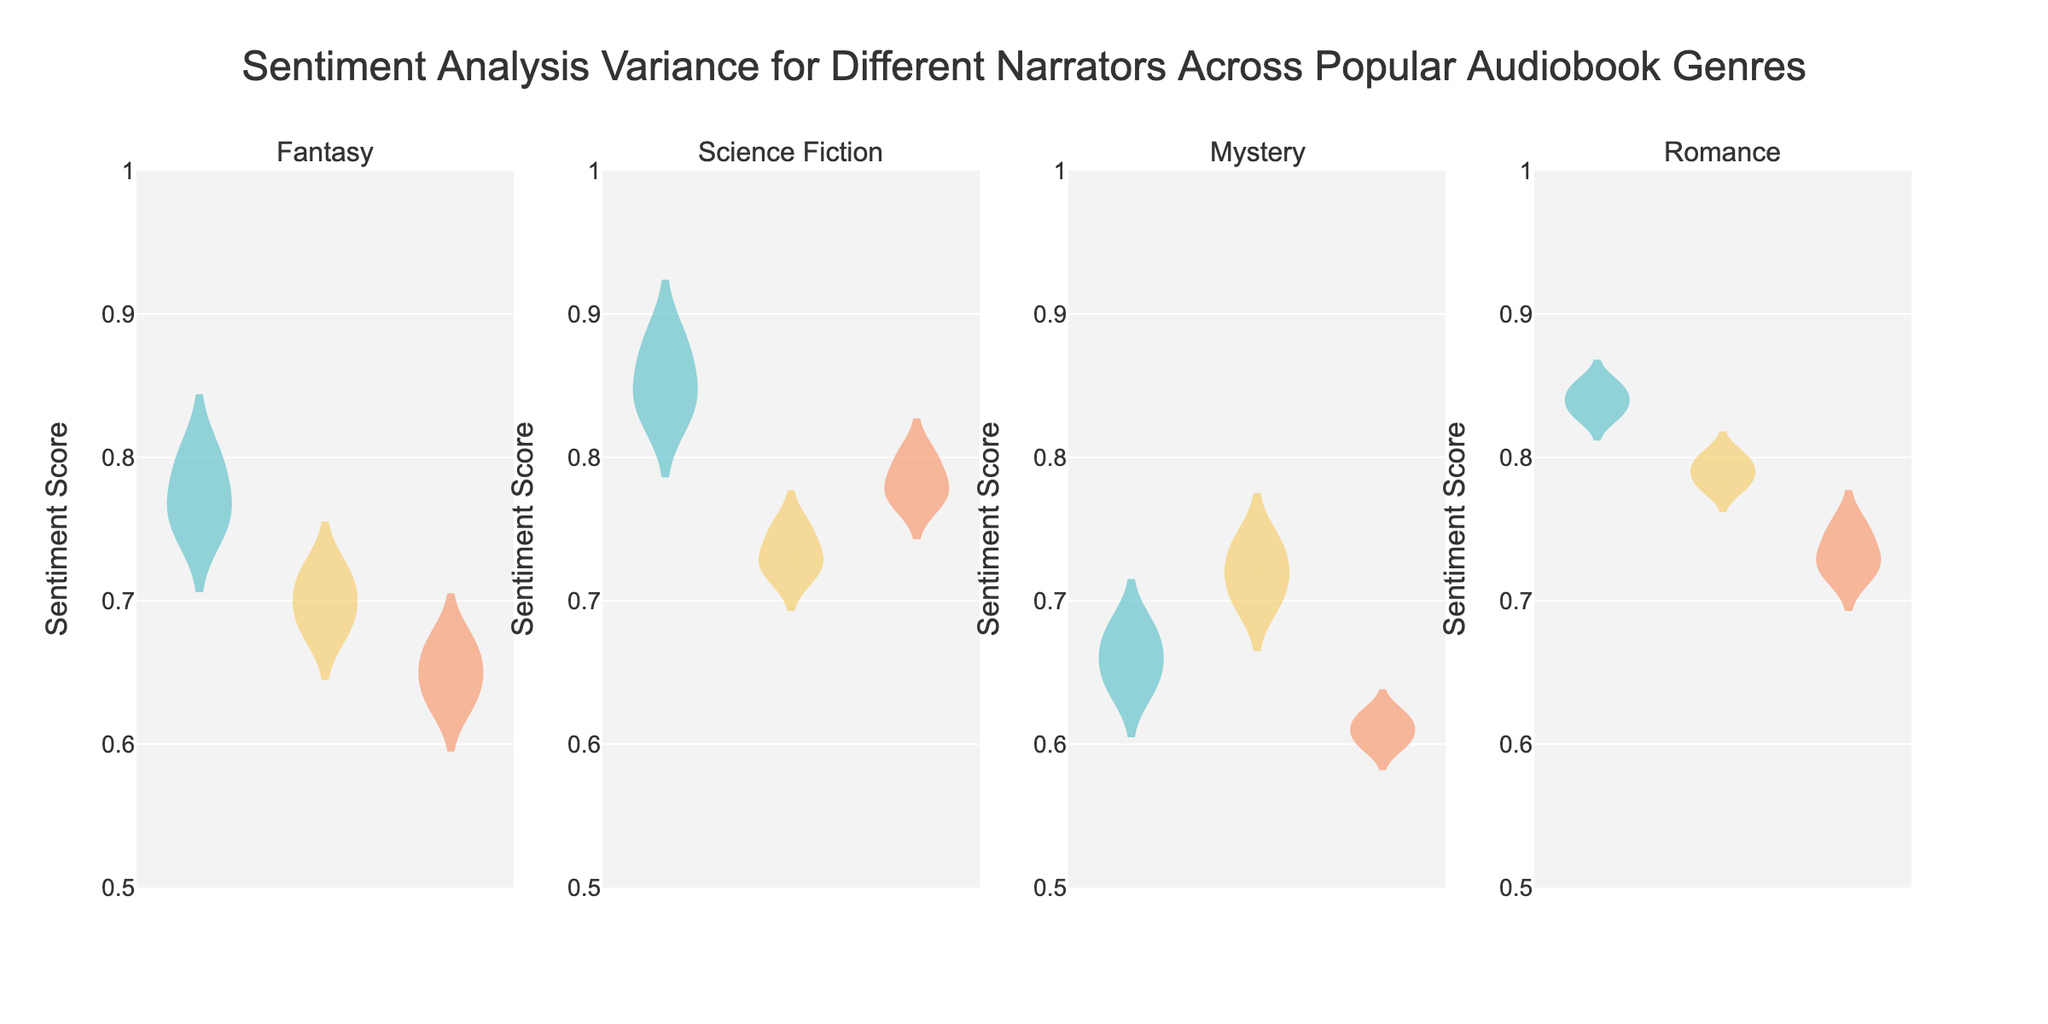What's the title of the chart? The title is typically displayed at the top of the chart, summarizing its content. It indicates what the chart is about.
Answer: Sentiment Analysis Variance for Different Narrators Across Popular Audiobook Genres What's the range of sentiment scores displayed on the y-axis? The y-axis shows the range of values for sentiment scores, which can be read directly from the axis labels.
Answer: 0.5 to 1 How many genres are compared in this chart? Each subplot represents a different genre. By counting the number of subplots, one can determine the number of genres compared.
Answer: Four Who has the highest median sentiment score among Fantasy narrators? The median is represented by a line inside the violin plot. By identifying the highest median line among Fantasy narrators, the narrator with the highest median is found.
Answer: Stephen Fry Which narrator in the Science Fiction genre has the widest sentiment score range? The width of the violin plot indicates the range. By comparing the widths of the plots for narrators in Science Fiction, the narrator with the widest range can be identified.
Answer: George Guidall What is the approximate sentiment score range for Rosamund Pike in the Mystery genre? By examining Rosamund Pike's violin plot in the Mystery genre, one can estimate the range from the lowest to the highest values shown in the plot.
Answer: 0.60 to 0.62 Compare the mean sentiment scores of Romance narrators. Who has the highest mean? The mean is indicated by a line within the box plot part of the violin plot. By comparing these mean lines across Romance narrators, the narrator with the highest mean can be determined.
Answer: Julia Whelan In which genre is the sentiment score variance the smallest? Variance can be inferred from the width and spread of the violin plots across genres. The genre with the most condensed and narrow violin plots has the smallest variance.
Answer: Mystery Which narrator in the Fantasy genre has the narrowest sentiment score distribution? The narrowest distribution will show the least spread in the violin plot. By visual inspection, the narrator with the smallest spread in the Fantasy genre can be identified.
Answer: Kate Reading 